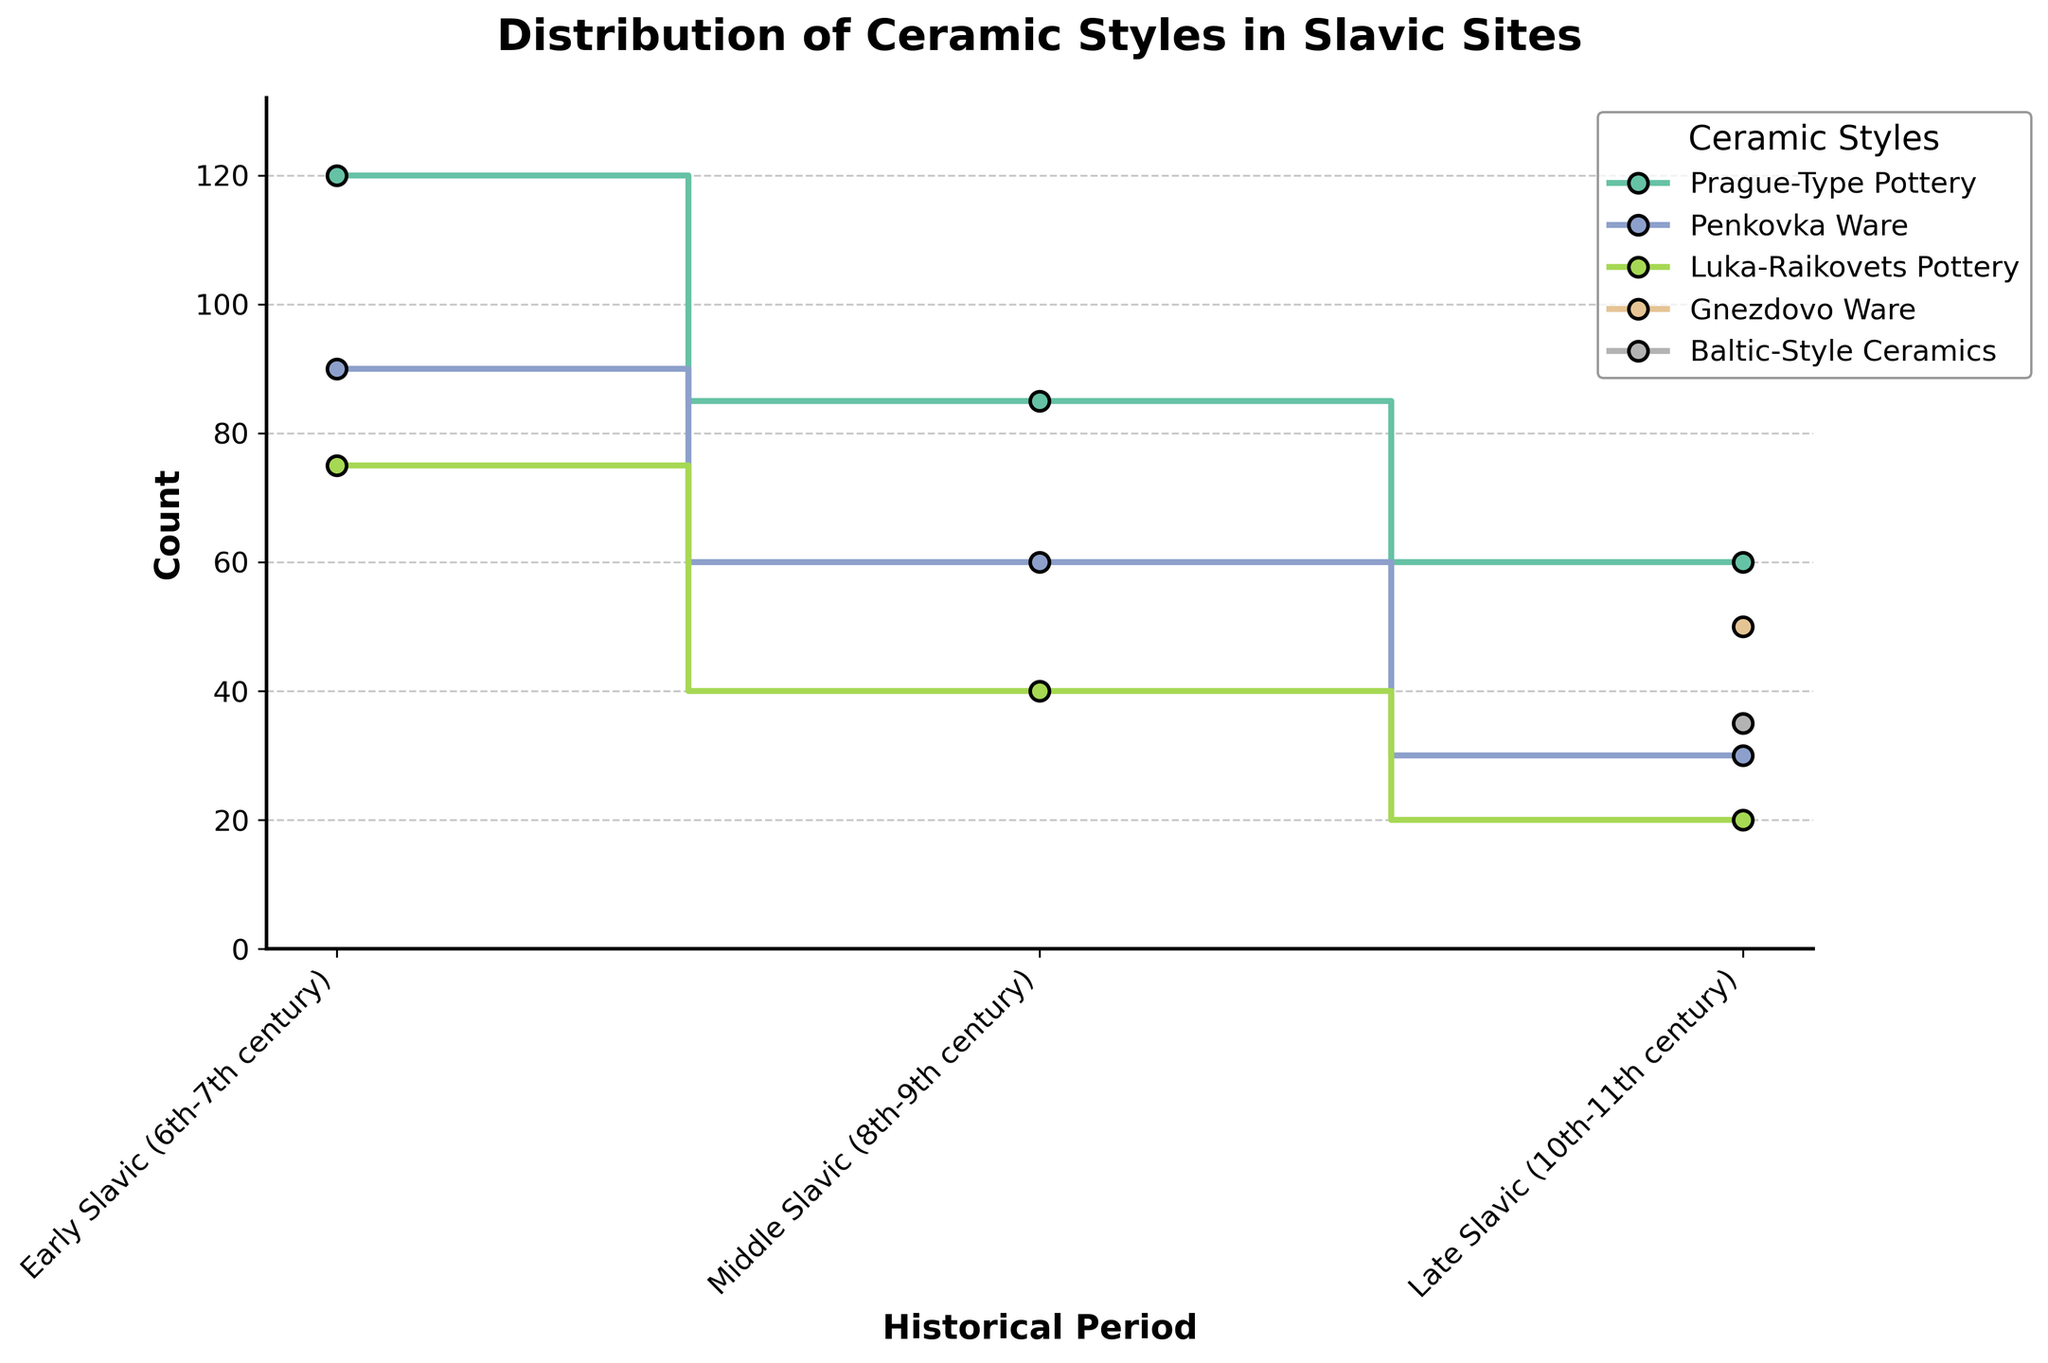What's the title of the figure? The title of the figure is displayed at the top. It helps provide an overall context for the data being shown.
Answer: Distribution of Ceramic Styles in Slavic Sites Which ceramic style has the highest count during the Early Slavic period? Refer to the ‘Early Slavic (6th-7th century)’ period on the x-axis, then check the y-axis for the ceramic style with the highest value. It's the style with the highest step mark.
Answer: Prague-Type Pottery How many ceramic styles are displayed in the Late Slavic period? Look at the x-axis for the ‘Late Slavic (10th-11th century)’ period, then count the different ceramic styles presented in that period.
Answer: 5 What is the count for Penkovka Ware during the Middle Slavic period? Locate the 'Middle Slavic (8th-9th century)' period on the x-axis and refer to the line representing Penkovka Ware. The y-axis value where this line steps is the count.
Answer: 60 Which ceramic style shows the greatest decline in count from Early Slavic to Middle Slavic period? Observe the difference in the count values (y-axis) for each ceramic style between the 'Early Slavic (6th-7th century)' and 'Middle Slavic (8th-9th century)' periods.
Answer: Prague-Type Pottery What is the average count of Luka-Raikovets Pottery across all periods? Retrieve the count values for Luka-Raikovets Pottery for all periods: 75 (Early Slavic), 40 (Middle Slavic), and 20 (Late Slavic). Calculate the average of these values: (75+40+20)/3.
Answer: 45 In which period does Prague-Type Pottery have the lowest count? Identify the counts of Prague-Type Pottery in each period and find the period with the smallest count value.
Answer: Late Slavic (10th-11th century) Which ceramic style appears only in the Late Slavic period? Examine the ceramic styles listed and identify the one that is present only in the 'Late Slavic (10th-11th century)' period and not in the earlier periods.
Answer: Gnezdovo Ware Compare the total counts of all ceramic styles between the Early Slavic and Late Slavic periods. Calculate the sum of counts for all ceramic styles in the 'Early Slavic (6th-7th century)' and 'Late Slavic (10th-11th century)' periods. (120+90+75) for Early Slavic and (60+30+20+50+35) for Late Slavic, then compare.
Answer: Early Slavic has a higher total count How does the distribution of ceramic styles in the Middle Slavic period differ from that in the Late Slavic period? Look at the count values for each ceramic style in both periods and note the differences and trends. Discuss specific styles and how their counts change between these periods.
Answer: Middle Slavic has fewer styles and lower counts overall 